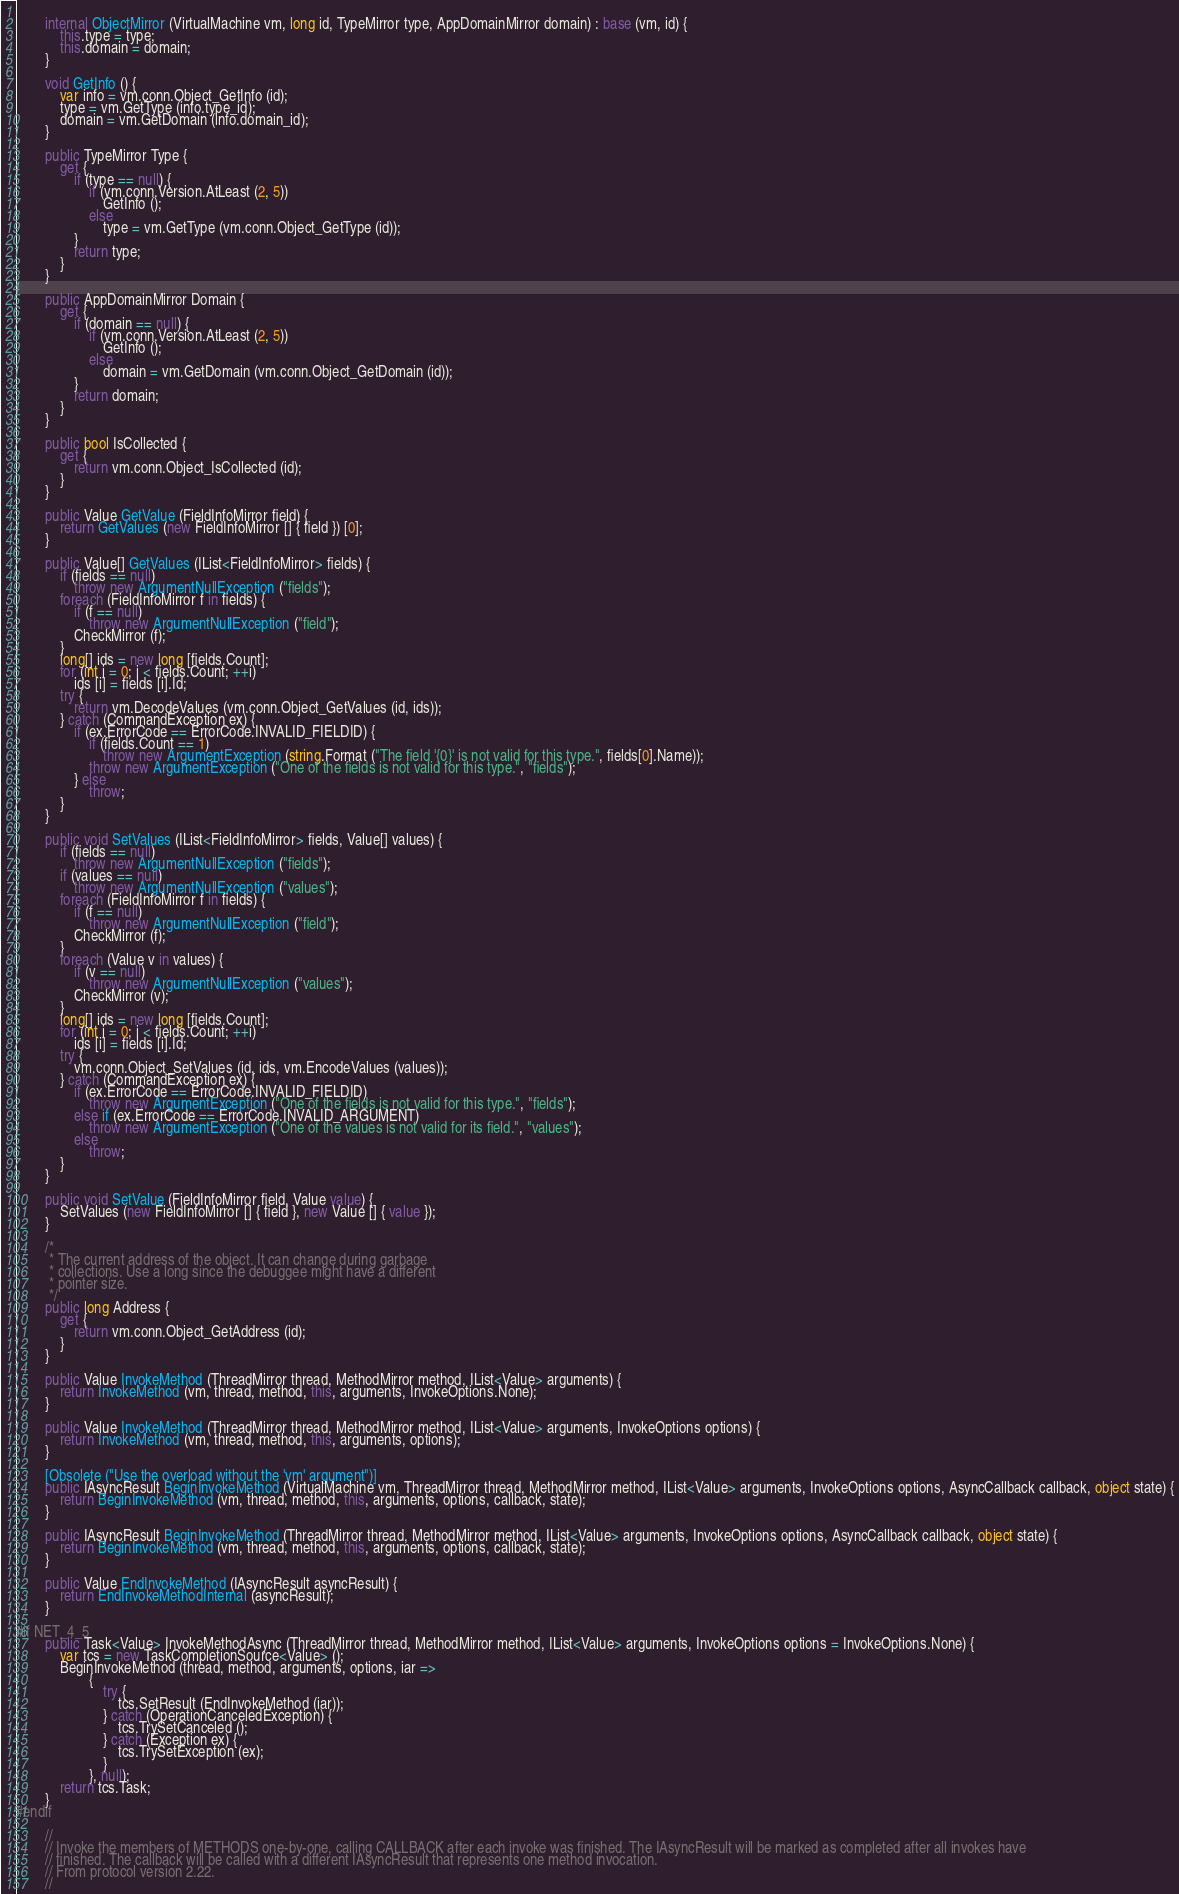Convert code to text. <code><loc_0><loc_0><loc_500><loc_500><_C#_>	
		internal ObjectMirror (VirtualMachine vm, long id, TypeMirror type, AppDomainMirror domain) : base (vm, id) {
			this.type = type;
			this.domain = domain;
		}

		void GetInfo () {
			var info = vm.conn.Object_GetInfo (id);
			type = vm.GetType (info.type_id);
			domain = vm.GetDomain (info.domain_id);
		}

		public TypeMirror Type {
			get {
				if (type == null) {
					if (vm.conn.Version.AtLeast (2, 5))
						GetInfo ();
					else
				 		type = vm.GetType (vm.conn.Object_GetType (id));
				}
				return type;
			}
		}

		public AppDomainMirror Domain {
			get {
				if (domain == null) {
					if (vm.conn.Version.AtLeast (2, 5))
						GetInfo ();
					else
						domain = vm.GetDomain (vm.conn.Object_GetDomain (id));
				}
				return domain;
			}
		}

		public bool IsCollected {
			get {
				return vm.conn.Object_IsCollected (id);
			}
		}

		public Value GetValue (FieldInfoMirror field) {
			return GetValues (new FieldInfoMirror [] { field }) [0];
		}

		public Value[] GetValues (IList<FieldInfoMirror> fields) {
			if (fields == null)
				throw new ArgumentNullException ("fields");
			foreach (FieldInfoMirror f in fields) {
				if (f == null)
					throw new ArgumentNullException ("field");
				CheckMirror (f);
			}
			long[] ids = new long [fields.Count];
			for (int i = 0; i < fields.Count; ++i)
				ids [i] = fields [i].Id;
			try {
				return vm.DecodeValues (vm.conn.Object_GetValues (id, ids));
			} catch (CommandException ex) {
				if (ex.ErrorCode == ErrorCode.INVALID_FIELDID) {
					if (fields.Count == 1)
						throw new ArgumentException (string.Format ("The field '{0}' is not valid for this type.", fields[0].Name));
					throw new ArgumentException ("One of the fields is not valid for this type.", "fields");
				} else
					throw;
			}
		}

		public void SetValues (IList<FieldInfoMirror> fields, Value[] values) {
			if (fields == null)
				throw new ArgumentNullException ("fields");
			if (values == null)
				throw new ArgumentNullException ("values");
			foreach (FieldInfoMirror f in fields) {
				if (f == null)
					throw new ArgumentNullException ("field");
				CheckMirror (f);
			}
			foreach (Value v in values) {
				if (v == null)
					throw new ArgumentNullException ("values");
				CheckMirror (v);
			}
			long[] ids = new long [fields.Count];
			for (int i = 0; i < fields.Count; ++i)
				ids [i] = fields [i].Id;
			try {
				vm.conn.Object_SetValues (id, ids, vm.EncodeValues (values));
			} catch (CommandException ex) {
				if (ex.ErrorCode == ErrorCode.INVALID_FIELDID)
					throw new ArgumentException ("One of the fields is not valid for this type.", "fields");
				else if (ex.ErrorCode == ErrorCode.INVALID_ARGUMENT)
					throw new ArgumentException ("One of the values is not valid for its field.", "values");
				else
					throw;
			}
		}

		public void SetValue (FieldInfoMirror field, Value value) {
			SetValues (new FieldInfoMirror [] { field }, new Value [] { value });
		}

		/*
		 * The current address of the object. It can change during garbage 
		 * collections. Use a long since the debuggee might have a different 
		 * pointer size. 
		 */
		public long Address {
			get {
				return vm.conn.Object_GetAddress (id);
			}
		}

		public Value InvokeMethod (ThreadMirror thread, MethodMirror method, IList<Value> arguments) {
			return InvokeMethod (vm, thread, method, this, arguments, InvokeOptions.None);
		}

		public Value InvokeMethod (ThreadMirror thread, MethodMirror method, IList<Value> arguments, InvokeOptions options) {
			return InvokeMethod (vm, thread, method, this, arguments, options);
		}

		[Obsolete ("Use the overload without the 'vm' argument")]
		public IAsyncResult BeginInvokeMethod (VirtualMachine vm, ThreadMirror thread, MethodMirror method, IList<Value> arguments, InvokeOptions options, AsyncCallback callback, object state) {
			return BeginInvokeMethod (vm, thread, method, this, arguments, options, callback, state);
		}

		public IAsyncResult BeginInvokeMethod (ThreadMirror thread, MethodMirror method, IList<Value> arguments, InvokeOptions options, AsyncCallback callback, object state) {
			return BeginInvokeMethod (vm, thread, method, this, arguments, options, callback, state);
		}

		public Value EndInvokeMethod (IAsyncResult asyncResult) {
			return EndInvokeMethodInternal (asyncResult);
		}

#if NET_4_5
		public Task<Value> InvokeMethodAsync (ThreadMirror thread, MethodMirror method, IList<Value> arguments, InvokeOptions options = InvokeOptions.None) {
			var tcs = new TaskCompletionSource<Value> ();
			BeginInvokeMethod (thread, method, arguments, options, iar =>
					{
						try {
							tcs.SetResult (EndInvokeMethod (iar));
						} catch (OperationCanceledException) {
							tcs.TrySetCanceled ();
						} catch (Exception ex) {
							tcs.TrySetException (ex);
						}
					}, null);
			return tcs.Task;
		}
#endif

		//
		// Invoke the members of METHODS one-by-one, calling CALLBACK after each invoke was finished. The IAsyncResult will be marked as completed after all invokes have
		// finished. The callback will be called with a different IAsyncResult that represents one method invocation.
		// From protocol version 2.22.
		//</code> 